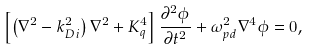<formula> <loc_0><loc_0><loc_500><loc_500>\left [ \left ( \nabla ^ { 2 } - k _ { D i } ^ { 2 } \right ) \nabla ^ { 2 } + K _ { q } ^ { 4 } \right ] \frac { \partial ^ { 2 } \phi } { \partial t ^ { 2 } } + \omega _ { p d } ^ { 2 } \nabla ^ { 4 } \phi = 0 ,</formula> 